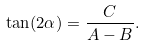<formula> <loc_0><loc_0><loc_500><loc_500>\tan ( 2 \alpha ) = { \frac { C } { A - B } } .</formula> 